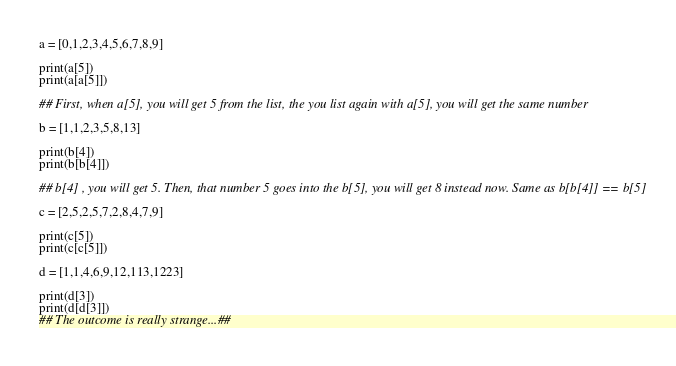Convert code to text. <code><loc_0><loc_0><loc_500><loc_500><_Python_>a = [0,1,2,3,4,5,6,7,8,9]

print(a[5])
print(a[a[5]])

## First, when a[5], you will get 5 from the list, the you list again with a[5], you will get the same number

b = [1,1,2,3,5,8,13]

print(b[4])
print(b[b[4]])

## b[4] , you will get 5. Then, that number 5 goes into the b[5], you will get 8 instead now. Same as b[b[4]] == b[5]

c = [2,5,2,5,7,2,8,4,7,9]

print(c[5])
print(c[c[5]])

d = [1,1,4,6,9,12,113,1223]

print(d[3])
print(d[d[3]])
## The outcome is really strange...##
</code> 